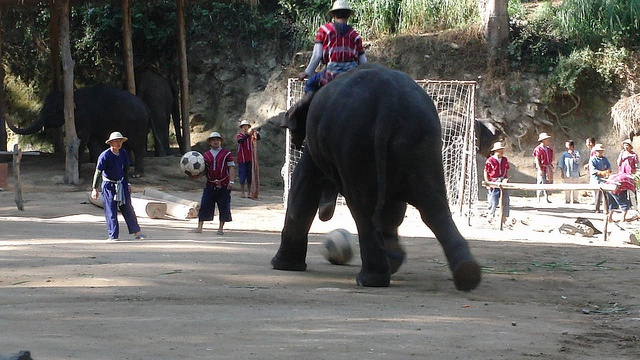Describe the objects in this image and their specific colors. I can see elephant in black, gray, and darkblue tones, elephant in black and gray tones, people in black, navy, darkgray, and gray tones, people in black, gray, maroon, and darkgray tones, and people in black, gray, purple, and ivory tones in this image. 